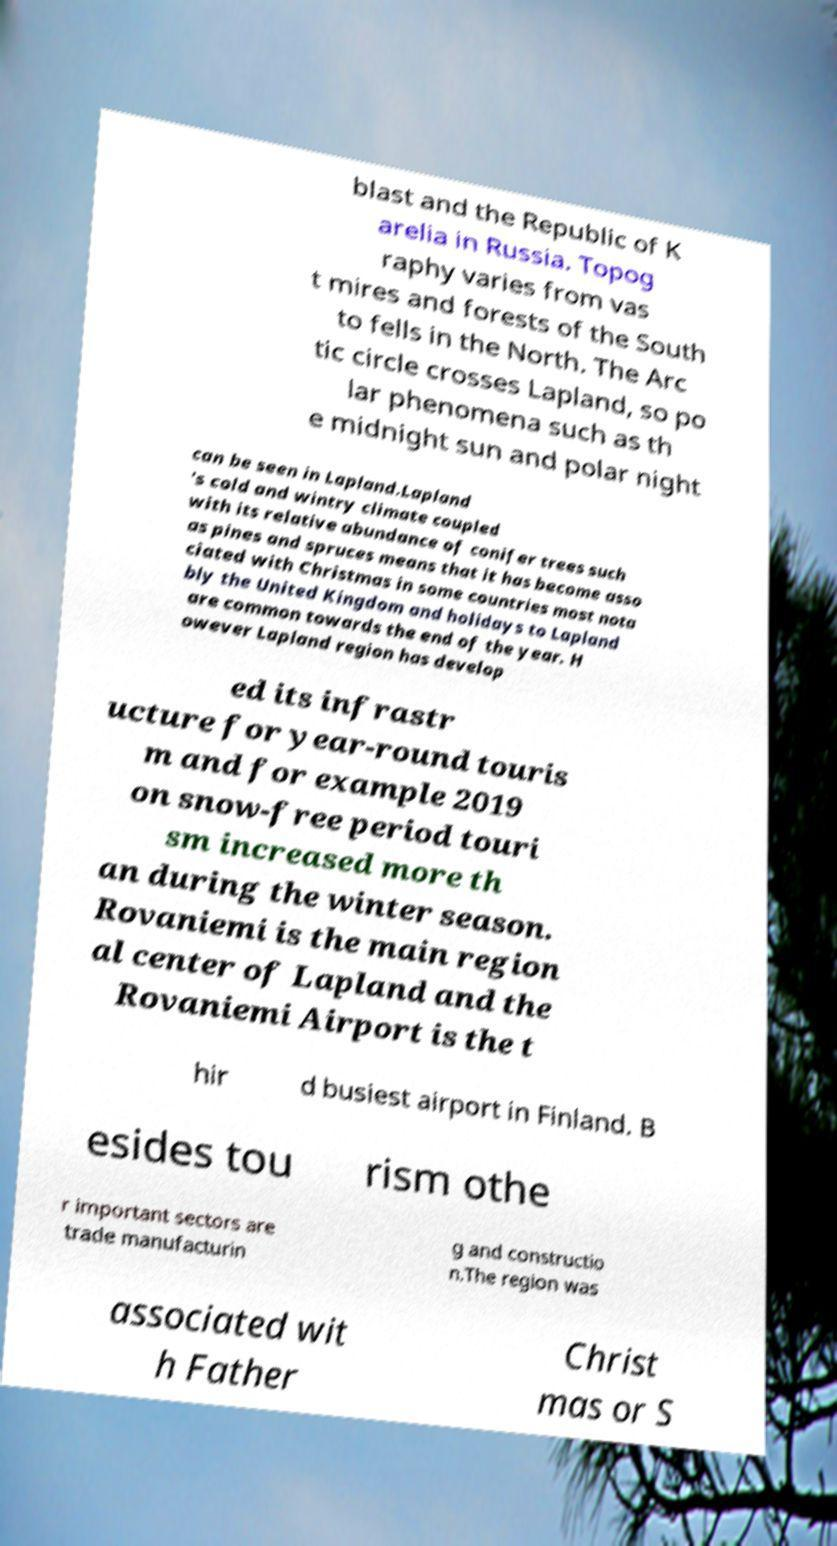For documentation purposes, I need the text within this image transcribed. Could you provide that? blast and the Republic of K arelia in Russia. Topog raphy varies from vas t mires and forests of the South to fells in the North. The Arc tic circle crosses Lapland, so po lar phenomena such as th e midnight sun and polar night can be seen in Lapland.Lapland 's cold and wintry climate coupled with its relative abundance of conifer trees such as pines and spruces means that it has become asso ciated with Christmas in some countries most nota bly the United Kingdom and holidays to Lapland are common towards the end of the year. H owever Lapland region has develop ed its infrastr ucture for year-round touris m and for example 2019 on snow-free period touri sm increased more th an during the winter season. Rovaniemi is the main region al center of Lapland and the Rovaniemi Airport is the t hir d busiest airport in Finland. B esides tou rism othe r important sectors are trade manufacturin g and constructio n.The region was associated wit h Father Christ mas or S 